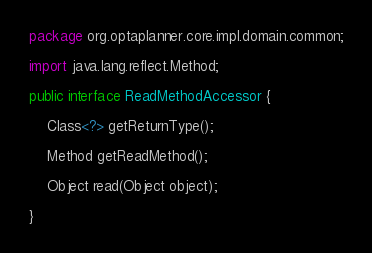<code> <loc_0><loc_0><loc_500><loc_500><_Java_>package org.optaplanner.core.impl.domain.common;

import java.lang.reflect.Method;

public interface ReadMethodAccessor {

    Class<?> getReturnType();

    Method getReadMethod();

    Object read(Object object);

}
</code> 